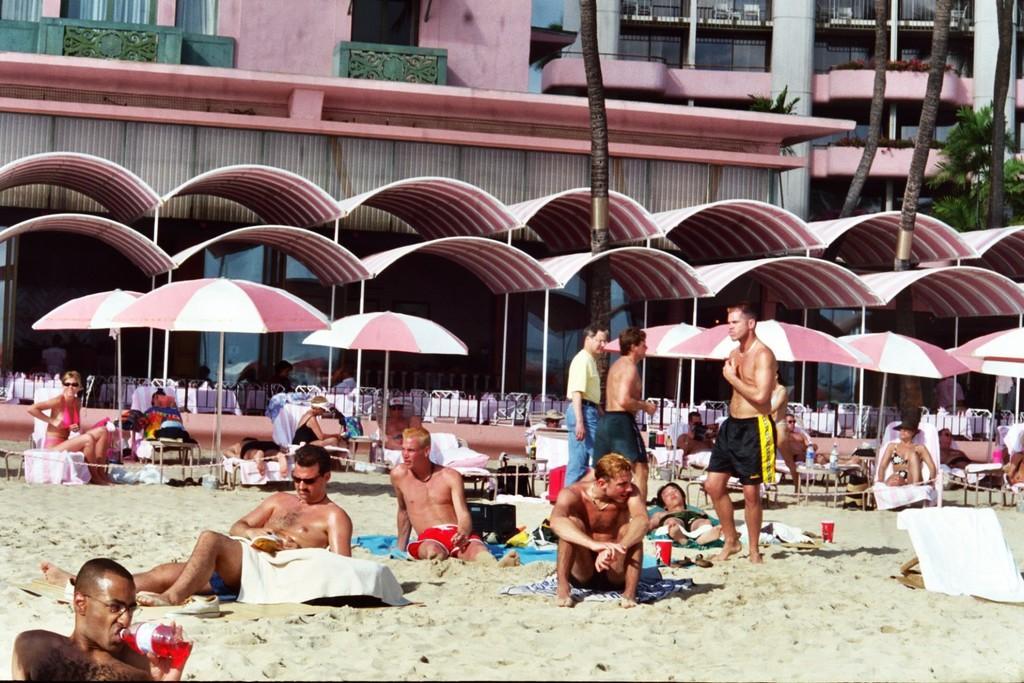Could you give a brief overview of what you see in this image? In this image there is mud at the bottom. There are people sitting and standing in the foreground. There are beach chairs, umbrellas, people, trees and there is a building in the background. 